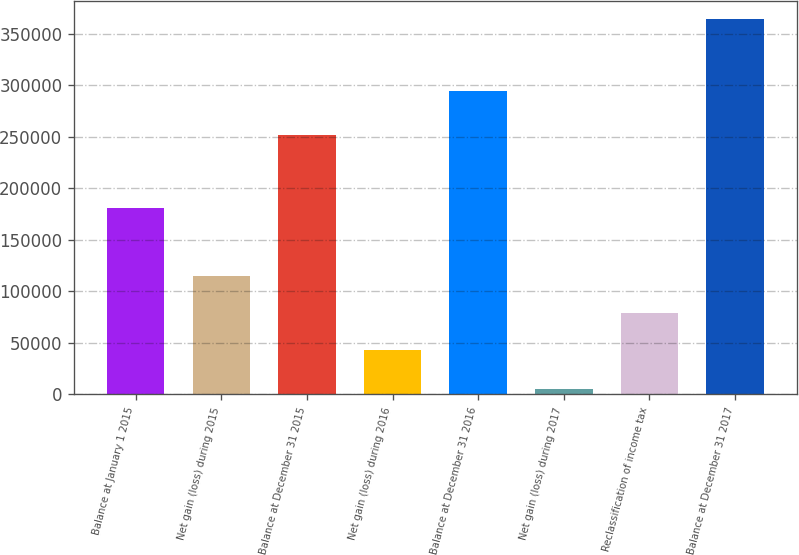Convert chart to OTSL. <chart><loc_0><loc_0><loc_500><loc_500><bar_chart><fcel>Balance at January 1 2015<fcel>Net gain (loss) during 2015<fcel>Balance at December 31 2015<fcel>Net gain (loss) during 2016<fcel>Balance at December 31 2016<fcel>Net gain (loss) during 2017<fcel>Reclassification of income tax<fcel>Balance at December 31 2017<nl><fcel>180994<fcel>114742<fcel>251627<fcel>43009<fcel>294636<fcel>5149<fcel>78875.5<fcel>363814<nl></chart> 